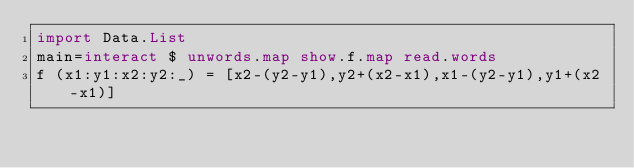Convert code to text. <code><loc_0><loc_0><loc_500><loc_500><_Haskell_>import Data.List
main=interact $ unwords.map show.f.map read.words
f (x1:y1:x2:y2:_) = [x2-(y2-y1),y2+(x2-x1),x1-(y2-y1),y1+(x2-x1)]</code> 